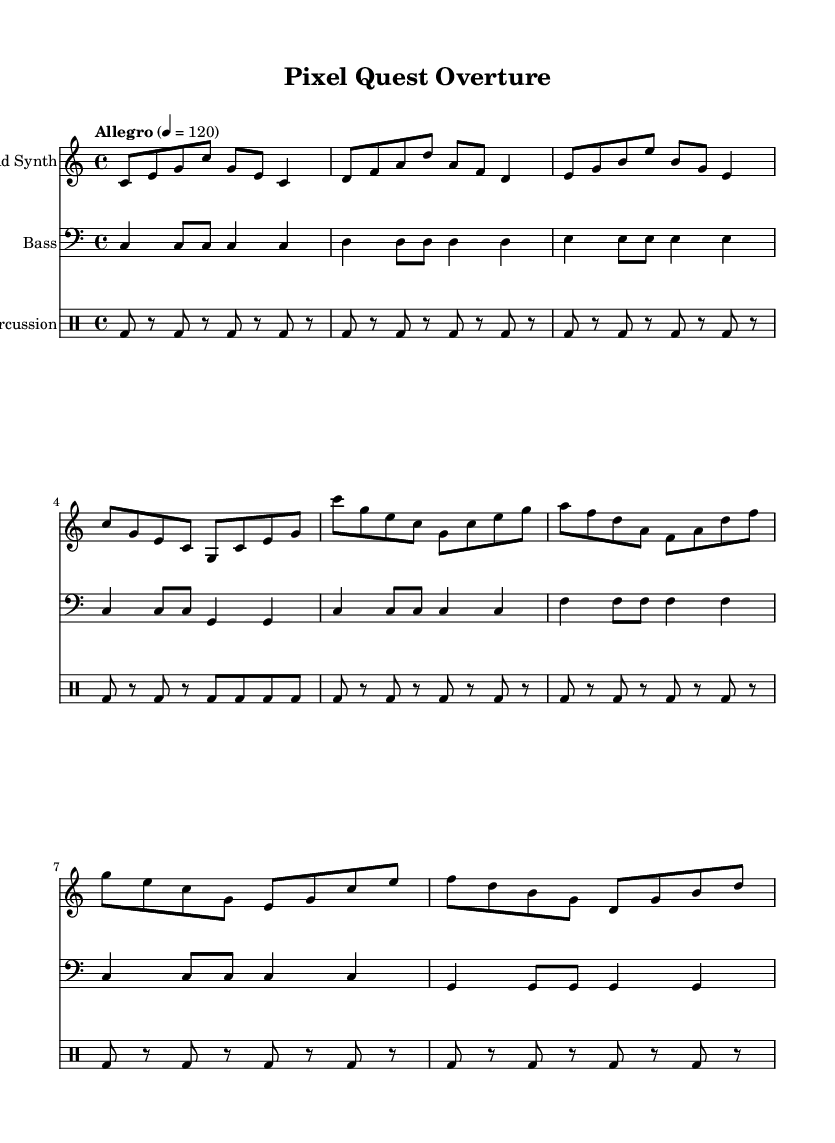What is the key signature of this music? The key signature is C major, which has no sharps or flats.
Answer: C major What is the time signature of this music? The time signature is denoted at the beginning of the score as 4/4, indicating four beats per measure.
Answer: 4/4 What is the tempo marking for this piece? The tempo marking is indicated as "Allegro", with a metronome marking of 120 beats per minute.
Answer: Allegro How many measures are in the introduction section of the lead synth part? The introduction of the lead synth consists of four measures as indicated by the grouping of notes.
Answer: 4 Which instrument plays the bass line? The bass line is specifically marked with a clef label indicating that the instrument is a bass, which visually guides the player.
Answer: Bass What rhythmic pattern is used in the percussion section for the introductory measures? The percussion section utilizes a steady bass drum rhythm, played in a repeated pattern alternating with rests in the first four measures.
Answer: Bass drum What is the highest note in the lead synth part? The highest note in the lead synth part is noted as c', situated above the treble staff, which is the highest pitch played in that section.
Answer: c' 